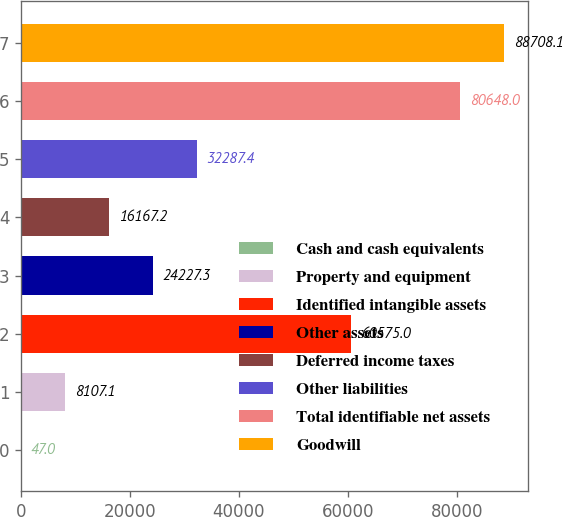Convert chart. <chart><loc_0><loc_0><loc_500><loc_500><bar_chart><fcel>Cash and cash equivalents<fcel>Property and equipment<fcel>Identified intangible assets<fcel>Other assets<fcel>Deferred income taxes<fcel>Other liabilities<fcel>Total identifiable net assets<fcel>Goodwill<nl><fcel>47<fcel>8107.1<fcel>60575<fcel>24227.3<fcel>16167.2<fcel>32287.4<fcel>80648<fcel>88708.1<nl></chart> 